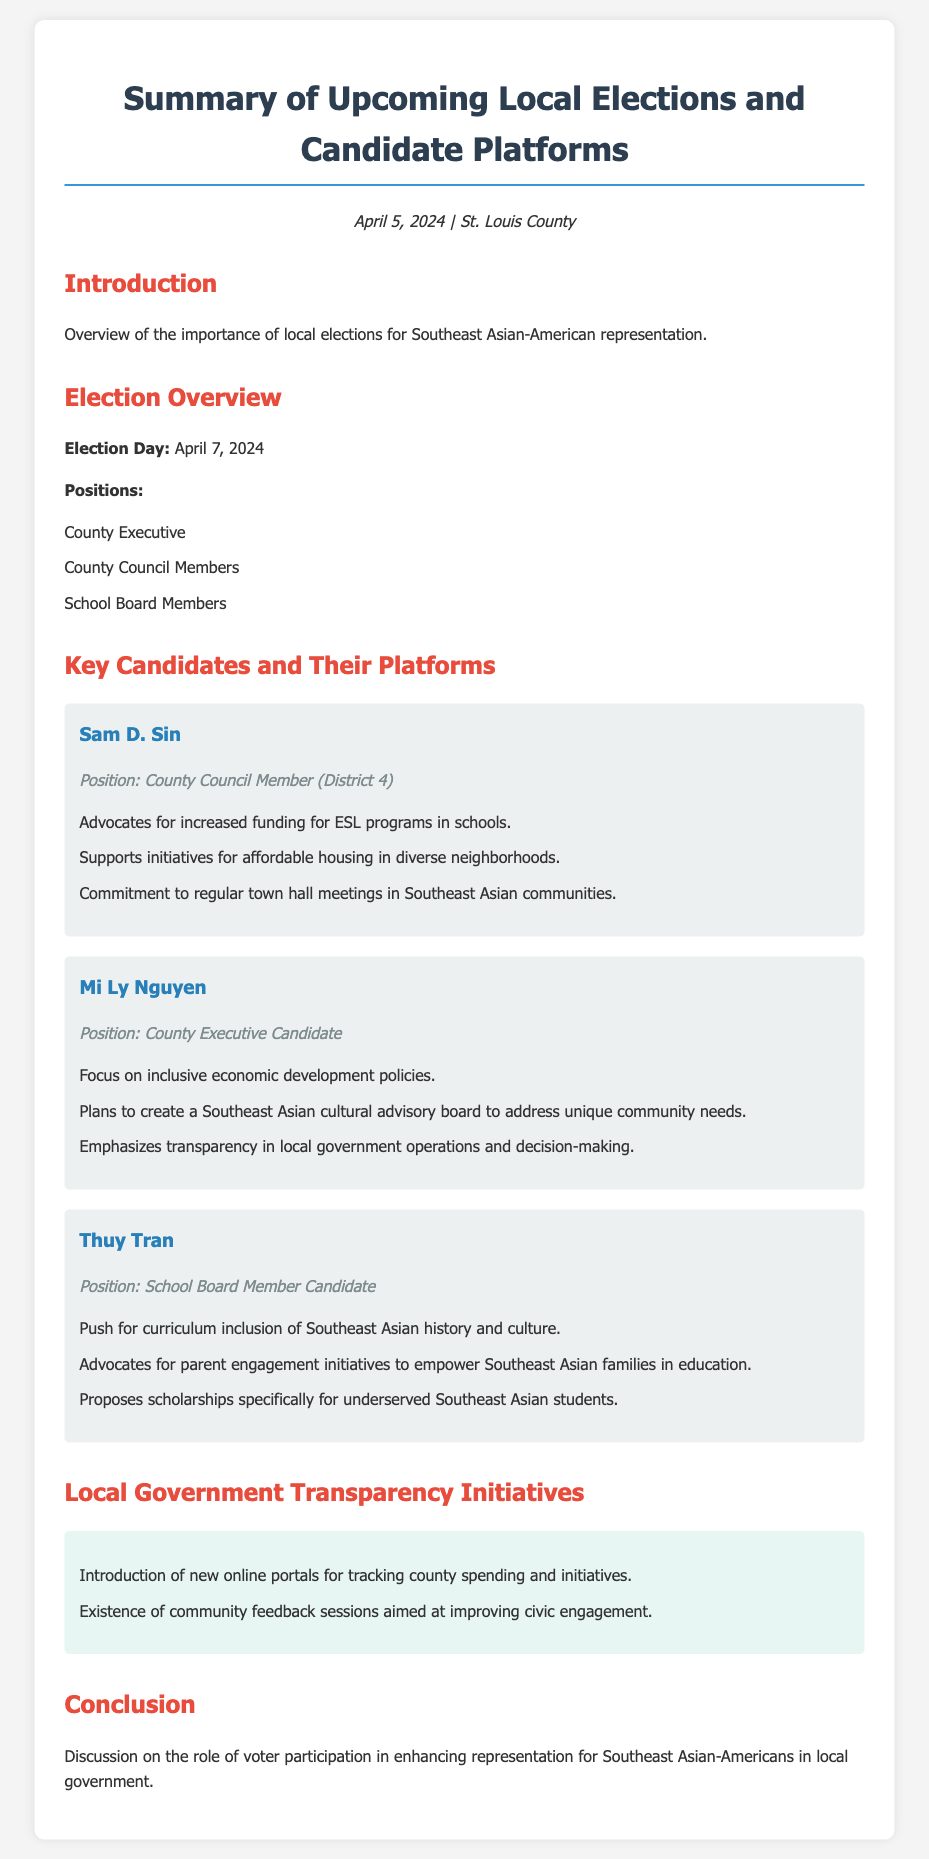What is the election date? The election date is stated clearly in the document under "Election Overview."
Answer: April 7, 2024 Who is running for County Executive? The document lists candidates for various positions; for County Executive, the candidate is highlighted.
Answer: Mi Ly Nguyen What initiative does Sam D. Sin support? The document mentions several initiatives under Sam D. Sin's platform; at least one is specifically described.
Answer: Increased funding for ESL programs How many candidates are mentioned for the School Board position? The document provides information about candidates for three different positions, including the School Board.
Answer: One What cultural group does Mi Ly Nguyen plan to address with an advisory board? The candidate’s platform focuses on a specific community that reflects her intent to represent.
Answer: Southeast Asian What transparency initiative is introduced by local government? The document outlines initiatives related to transparency in government operations, highlighting one of them.
Answer: Online portals for tracking county spending What is Thuy Tran advocating for in schools? The document outlines specific advocacy points for Thuy Tran regarding school curriculum and engagement.
Answer: Curriculum inclusion of Southeast Asian history What is one purpose of the community feedback sessions? The document briefly mentions the aims of these sessions in the context of civic engagement.
Answer: Improving civic engagement 